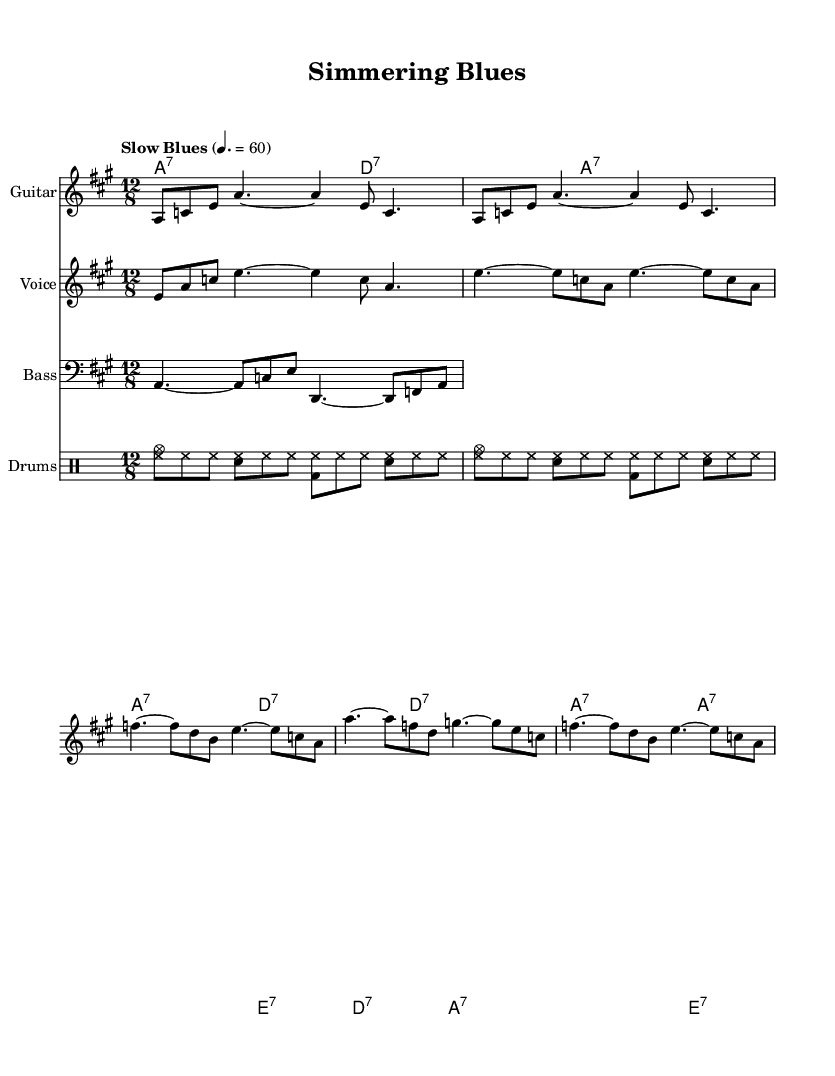What is the key signature of this music? The key signature is indicated by the key signature marking at the beginning of the staff, which shows two sharps. This corresponds to the key of A major.
Answer: A major What is the time signature of this music? The time signature is found at the beginning of the score, signified by two numbers stacked on top of each other. The numerator is 12, while the denominator is 8, indicating a 12/8 time signature.
Answer: 12/8 What is the tempo marking for this piece? The tempo marking is present at the start of the score, which specifies "Slow Blues" and a metronome marking of 60 quarter notes per minute.
Answer: Slow Blues What is the main theme of the lyrics in the verse? The main theme of the lyrics can be found in the first verse, which expresses the narrator's experiences and challenges faced during a long culinary career. The keywords hint at the essence of storytelling in cooking.
Answer: Culinary career How many times is the chord A7 played in the harmonies? By counting the instances of the A7 chord in the harmonies section, we see it occurs in every bar except for the one with the E7 chord. This totals to four instances throughout the provided harmonies.
Answer: Four What distinguishes the blues structure in this piece? This composition follows a standard 12-bar blues structure, which can be identified through its chord progression and lyrical phrasing, creating a repetitive and cyclical nature characteristic of blues music.
Answer: 12-bar blues 